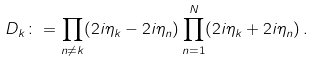<formula> <loc_0><loc_0><loc_500><loc_500>D _ { k } \colon = \prod _ { n \neq k } ( 2 i \eta _ { k } - 2 i \eta _ { n } ) \prod _ { n = 1 } ^ { N } ( 2 i \eta _ { k } + 2 i \eta _ { n } ) \, .</formula> 